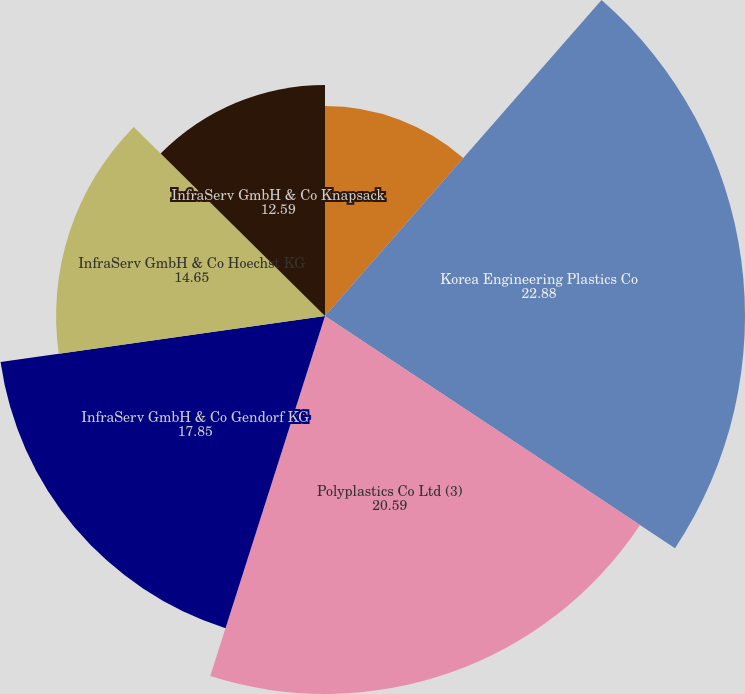Convert chart. <chart><loc_0><loc_0><loc_500><loc_500><pie_chart><fcel>Ibn Sina<fcel>Korea Engineering Plastics Co<fcel>Polyplastics Co Ltd (3)<fcel>InfraServ GmbH & Co Gendorf KG<fcel>InfraServ GmbH & Co Hoechst KG<fcel>InfraServ GmbH & Co Knapsack<nl><fcel>11.44%<fcel>22.88%<fcel>20.59%<fcel>17.85%<fcel>14.65%<fcel>12.59%<nl></chart> 